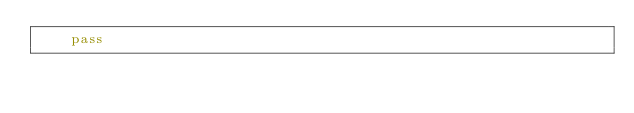Convert code to text. <code><loc_0><loc_0><loc_500><loc_500><_Python_>    pass
</code> 